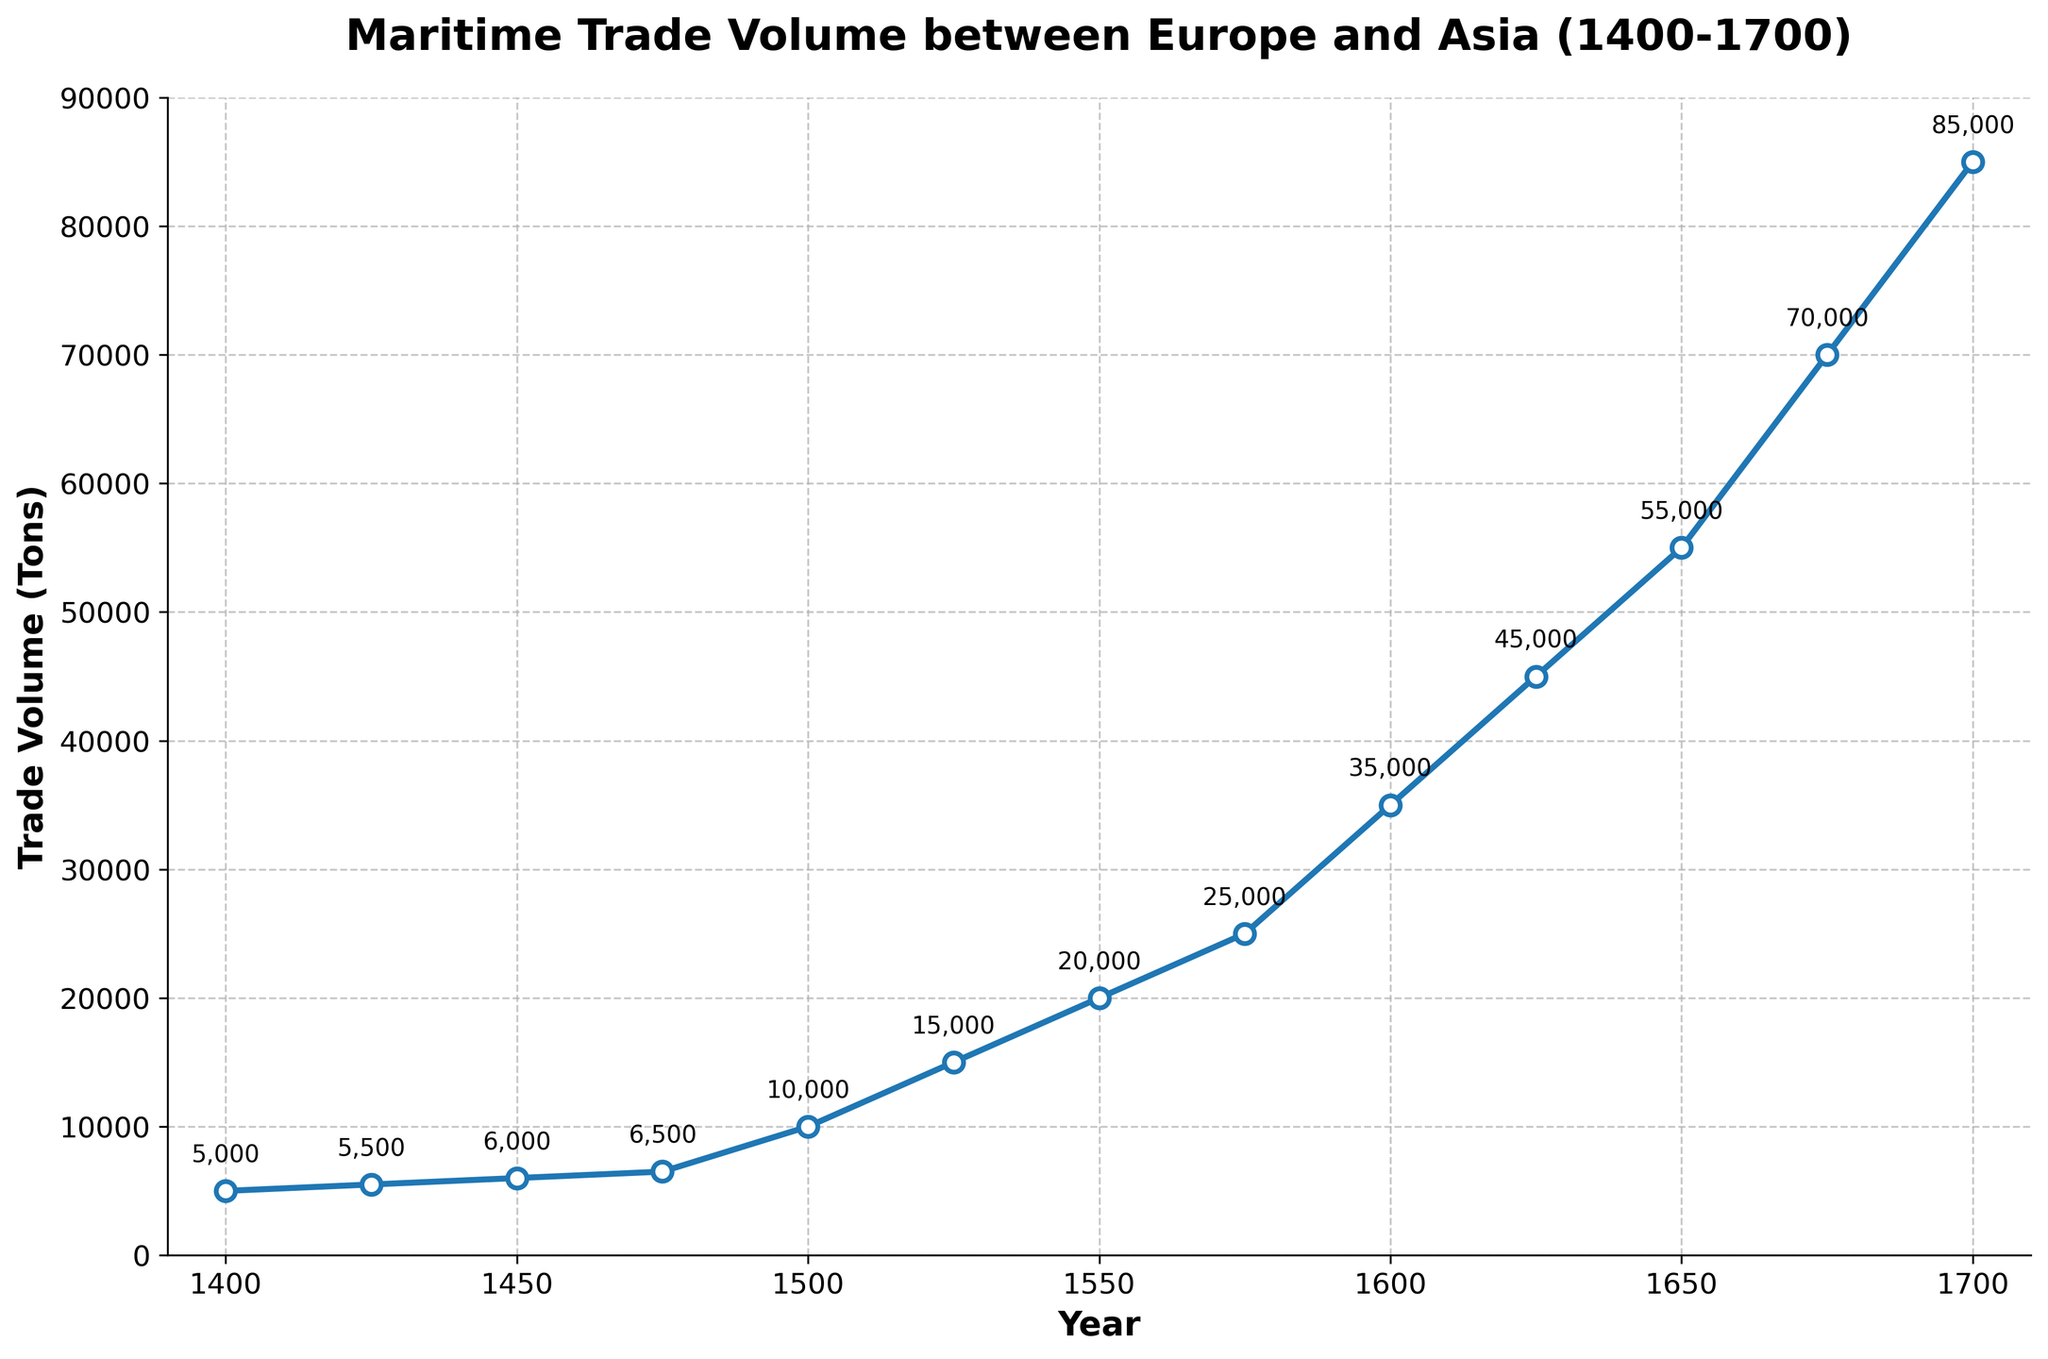How many data points are plotted in the figure? The figure has data points for each year from 1400 to 1700 at 25-year intervals.
Answer: 13 What is the trade volume for the year 1500? According to the figure, the annotation on the data point for the year 1500 indicates the trade volume.
Answer: 10,000 tons By how many tons did the trade volume increase from 1400 to 1700? The trade volume in 1400 was 5000 tons and in 1700 it increased to 85000 tons; subtracting the former from the latter gives the increase in tons.
Answer: 80,000 tons Which period saw the largest increase in trade volume? By examining the slope between consecutive points, the period from 1650 to 1700 shows the largest jump (55,000 to 85,000).
Answer: 1650 to 1700 What is the average trade volume from 1400 to 1500? The trade volumes for 1400, 1425, 1450, 1475, and 1500 are: 5000, 5500, 6000, 6500, and 10000. Sum these values and divide by the number of data points (5).
Answer: 7050 tons What is the title of the figure? The title of the figure is prominently displayed at the top.
Answer: Maritime Trade Volume between Europe and Asia (1400-1700) How does the trade volume in 1600 compare to that in 1500? The trade volume in 1600 is 35000 tons, whereas in 1500 it is 10000 tons. Therefore, the trade volume in 1600 is higher.
Answer: Higher What is the trend of the trade volume from 1400 to 1700? Observing the line plot, the trade volume shows a consistent upward trend over this period.
Answer: Upward trend Between which years did the trade volume increase from 20000 tons to 35000 tons? Identifying the data points, trade volume increased from 20000 tons in 1550 to 35000 tons in 1600.
Answer: 1550 to 1600 What is the difference in trade volume between the years 1550 and 1650? The trade volume in 1550 was 20000 tons and in 1650 it was 55000 tons; the difference is calculated by subtracting the former from the latter.
Answer: 35,000 tons 